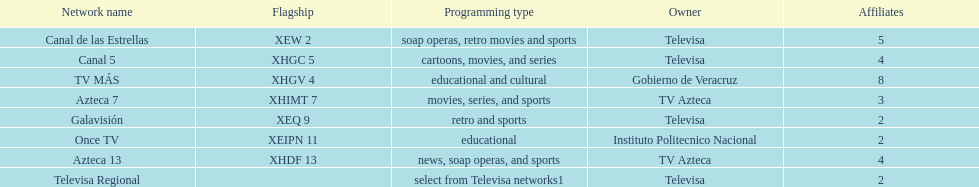Who has the most number of affiliates? TV MÁS. 